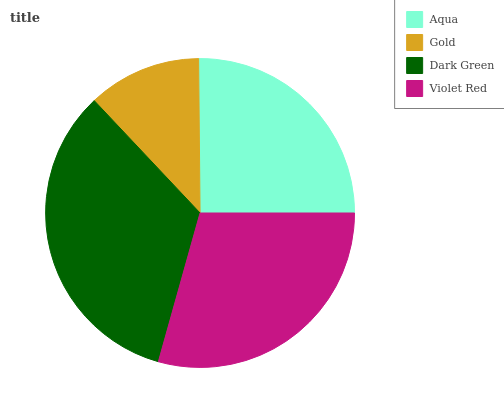Is Gold the minimum?
Answer yes or no. Yes. Is Dark Green the maximum?
Answer yes or no. Yes. Is Dark Green the minimum?
Answer yes or no. No. Is Gold the maximum?
Answer yes or no. No. Is Dark Green greater than Gold?
Answer yes or no. Yes. Is Gold less than Dark Green?
Answer yes or no. Yes. Is Gold greater than Dark Green?
Answer yes or no. No. Is Dark Green less than Gold?
Answer yes or no. No. Is Violet Red the high median?
Answer yes or no. Yes. Is Aqua the low median?
Answer yes or no. Yes. Is Aqua the high median?
Answer yes or no. No. Is Dark Green the low median?
Answer yes or no. No. 